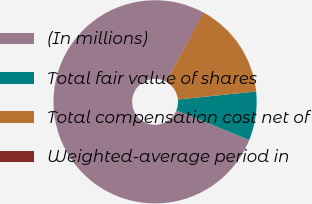<chart> <loc_0><loc_0><loc_500><loc_500><pie_chart><fcel>(In millions)<fcel>Total fair value of shares<fcel>Total compensation cost net of<fcel>Weighted-average period in<nl><fcel>76.76%<fcel>7.75%<fcel>15.41%<fcel>0.08%<nl></chart> 